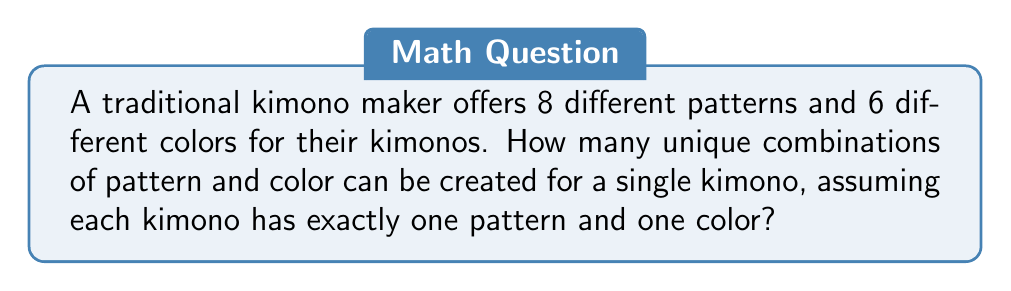Can you solve this math problem? To solve this problem, we'll use the multiplication principle of counting. This principle states that if we have two independent choices, where the first choice has $m$ options and the second choice has $n$ options, then the total number of possible combinations is $m \times n$.

In this case:
1. We have 8 different patterns to choose from for a kimono.
2. For each pattern, we have 6 different colors to choose from.

These choices are independent of each other, meaning the choice of pattern doesn't affect the choice of color and vice versa.

Therefore, we can calculate the total number of unique combinations as follows:

$$ \text{Total combinations} = \text{Number of patterns} \times \text{Number of colors} $$

$$ \text{Total combinations} = 8 \times 6 $$

$$ \text{Total combinations} = 48 $$

Thus, there are 48 unique combinations of pattern and color for a single kimono.
Answer: 48 